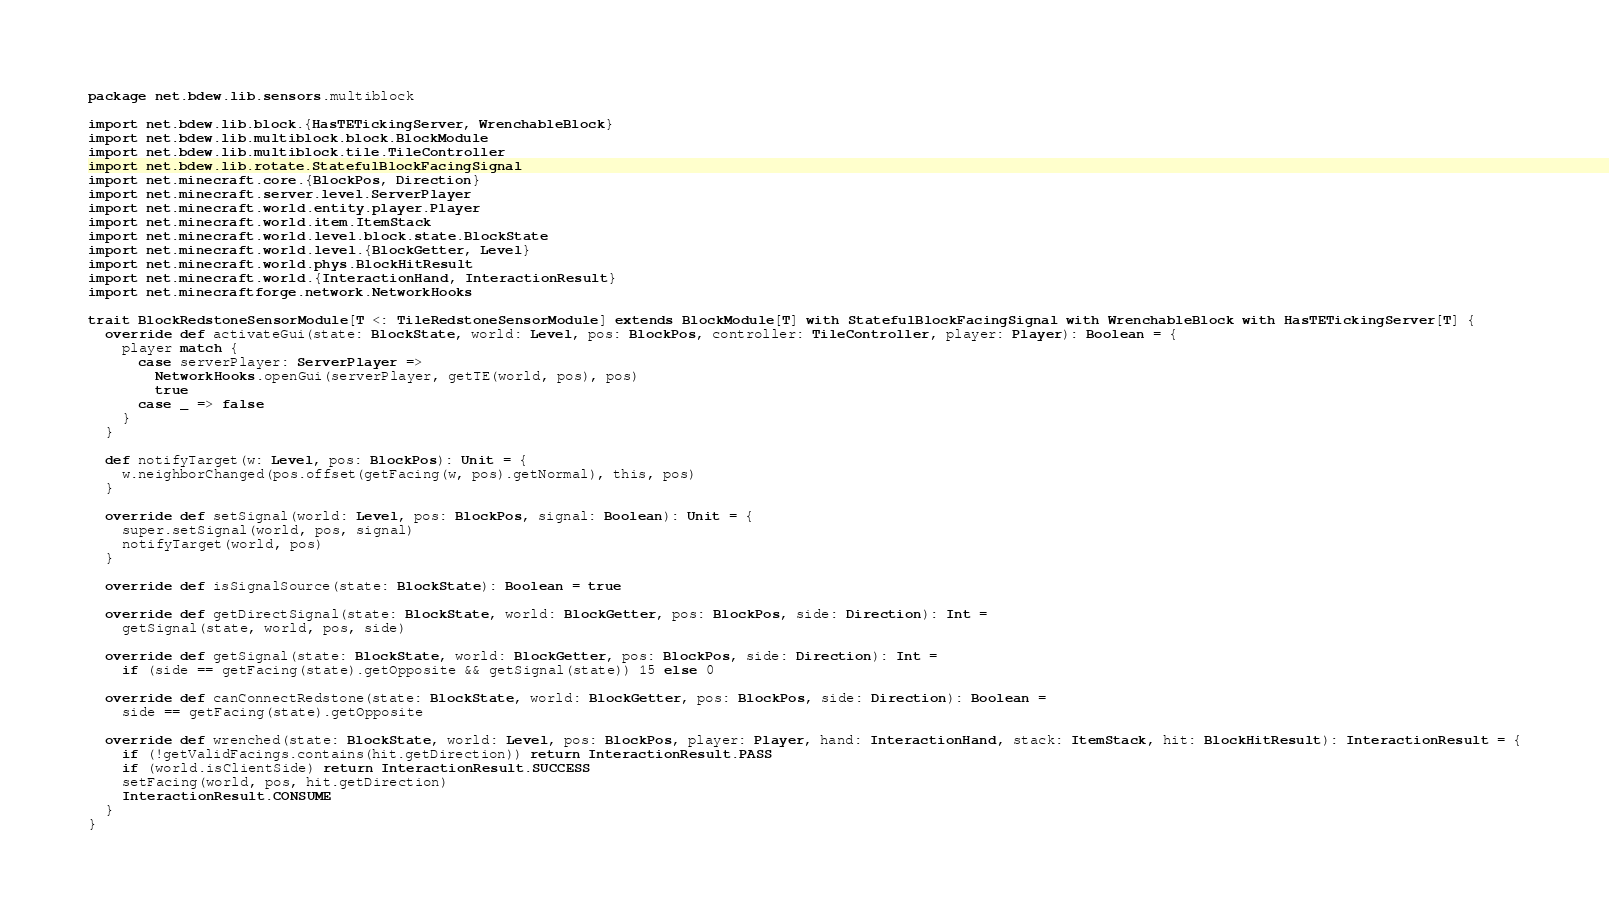Convert code to text. <code><loc_0><loc_0><loc_500><loc_500><_Scala_>package net.bdew.lib.sensors.multiblock

import net.bdew.lib.block.{HasTETickingServer, WrenchableBlock}
import net.bdew.lib.multiblock.block.BlockModule
import net.bdew.lib.multiblock.tile.TileController
import net.bdew.lib.rotate.StatefulBlockFacingSignal
import net.minecraft.core.{BlockPos, Direction}
import net.minecraft.server.level.ServerPlayer
import net.minecraft.world.entity.player.Player
import net.minecraft.world.item.ItemStack
import net.minecraft.world.level.block.state.BlockState
import net.minecraft.world.level.{BlockGetter, Level}
import net.minecraft.world.phys.BlockHitResult
import net.minecraft.world.{InteractionHand, InteractionResult}
import net.minecraftforge.network.NetworkHooks

trait BlockRedstoneSensorModule[T <: TileRedstoneSensorModule] extends BlockModule[T] with StatefulBlockFacingSignal with WrenchableBlock with HasTETickingServer[T] {
  override def activateGui(state: BlockState, world: Level, pos: BlockPos, controller: TileController, player: Player): Boolean = {
    player match {
      case serverPlayer: ServerPlayer =>
        NetworkHooks.openGui(serverPlayer, getTE(world, pos), pos)
        true
      case _ => false
    }
  }

  def notifyTarget(w: Level, pos: BlockPos): Unit = {
    w.neighborChanged(pos.offset(getFacing(w, pos).getNormal), this, pos)
  }

  override def setSignal(world: Level, pos: BlockPos, signal: Boolean): Unit = {
    super.setSignal(world, pos, signal)
    notifyTarget(world, pos)
  }

  override def isSignalSource(state: BlockState): Boolean = true

  override def getDirectSignal(state: BlockState, world: BlockGetter, pos: BlockPos, side: Direction): Int =
    getSignal(state, world, pos, side)

  override def getSignal(state: BlockState, world: BlockGetter, pos: BlockPos, side: Direction): Int =
    if (side == getFacing(state).getOpposite && getSignal(state)) 15 else 0

  override def canConnectRedstone(state: BlockState, world: BlockGetter, pos: BlockPos, side: Direction): Boolean =
    side == getFacing(state).getOpposite

  override def wrenched(state: BlockState, world: Level, pos: BlockPos, player: Player, hand: InteractionHand, stack: ItemStack, hit: BlockHitResult): InteractionResult = {
    if (!getValidFacings.contains(hit.getDirection)) return InteractionResult.PASS
    if (world.isClientSide) return InteractionResult.SUCCESS
    setFacing(world, pos, hit.getDirection)
    InteractionResult.CONSUME
  }
}
</code> 